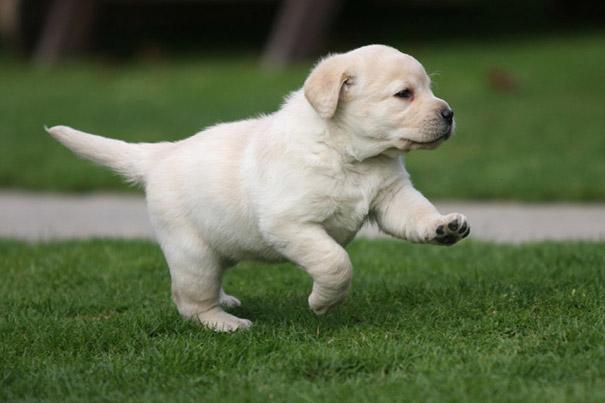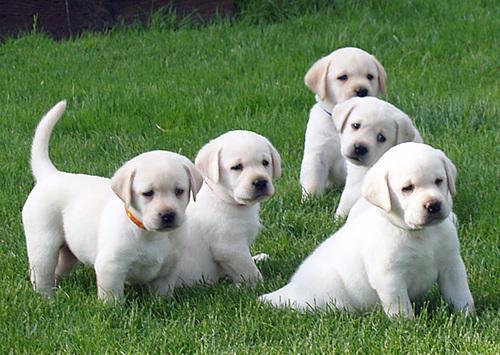The first image is the image on the left, the second image is the image on the right. Examine the images to the left and right. Is the description "Atleast 4 dogs total" accurate? Answer yes or no. Yes. The first image is the image on the left, the second image is the image on the right. Analyze the images presented: Is the assertion "There are at least three dogs in the right image." valid? Answer yes or no. Yes. 